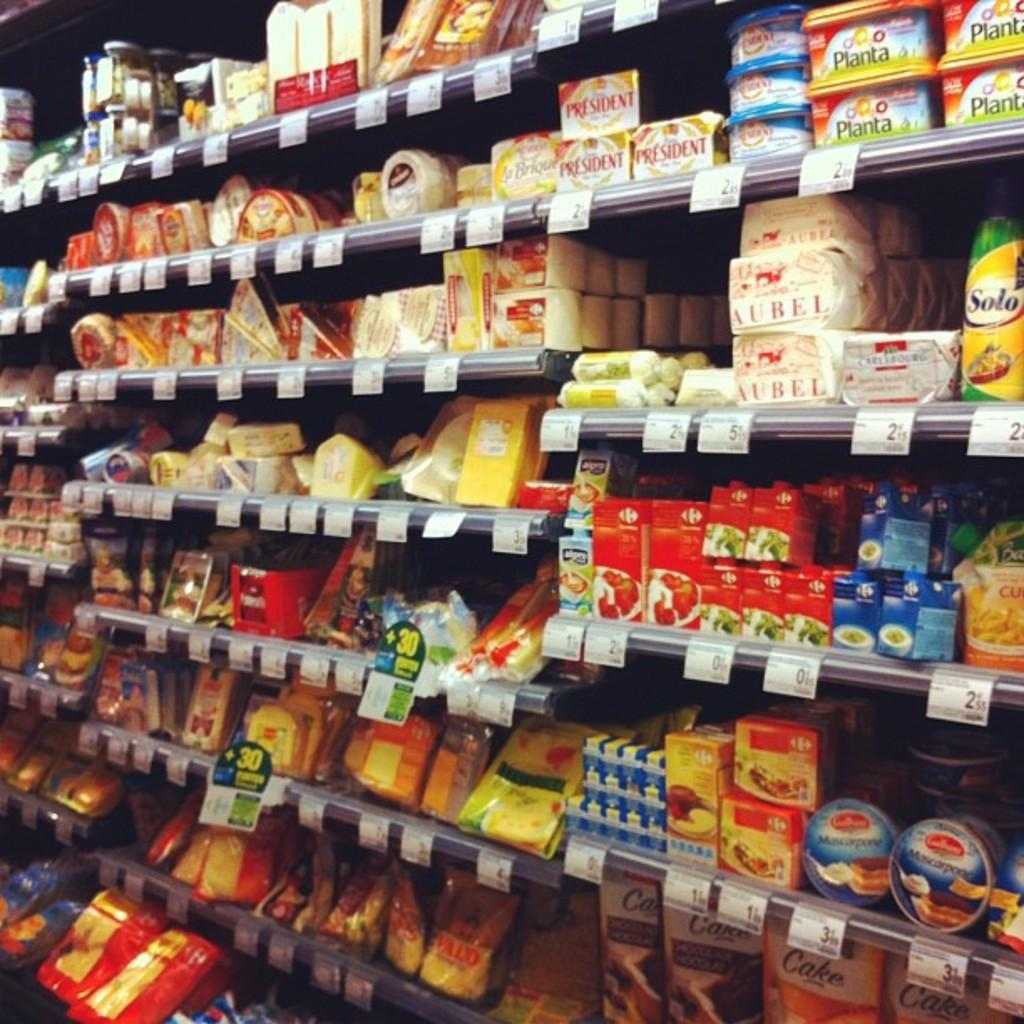<image>
Create a compact narrative representing the image presented. Shelves of different grocery products are displayed and a bag of cake mix on the right bottom corner. 